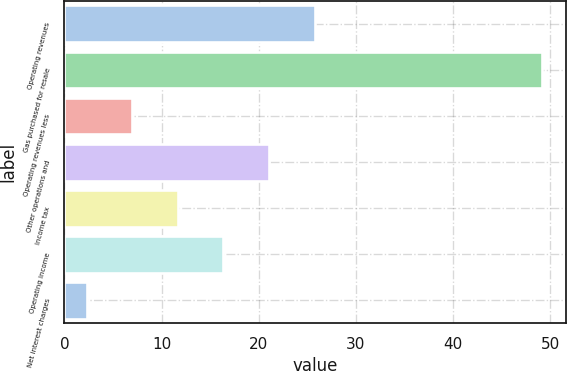<chart> <loc_0><loc_0><loc_500><loc_500><bar_chart><fcel>Operating revenues<fcel>Gas purchased for resale<fcel>Operating revenues less<fcel>Other operations and<fcel>Income tax<fcel>Operating income<fcel>Net interest charges<nl><fcel>25.75<fcel>49.2<fcel>6.99<fcel>21.06<fcel>11.68<fcel>16.37<fcel>2.3<nl></chart> 